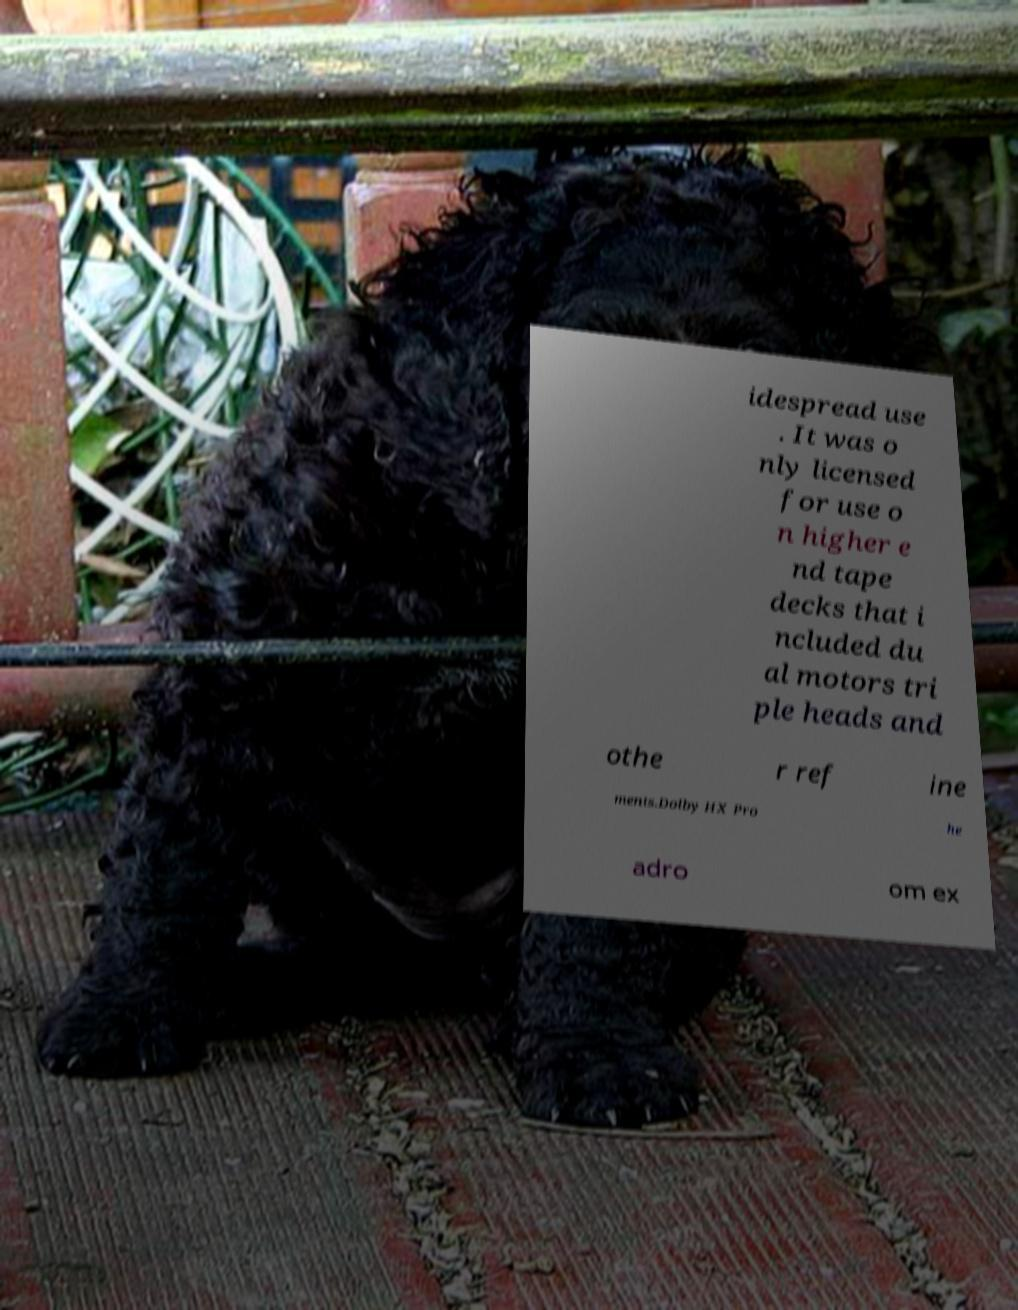For documentation purposes, I need the text within this image transcribed. Could you provide that? idespread use . It was o nly licensed for use o n higher e nd tape decks that i ncluded du al motors tri ple heads and othe r ref ine ments.Dolby HX Pro he adro om ex 